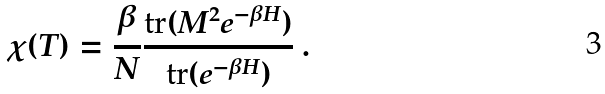<formula> <loc_0><loc_0><loc_500><loc_500>\chi ( T ) = \frac { \beta } { N } \frac { { \text {tr} } ( M ^ { 2 } e ^ { - \beta H } ) } { { \text {tr} } ( e ^ { - \beta H } ) } \ .</formula> 